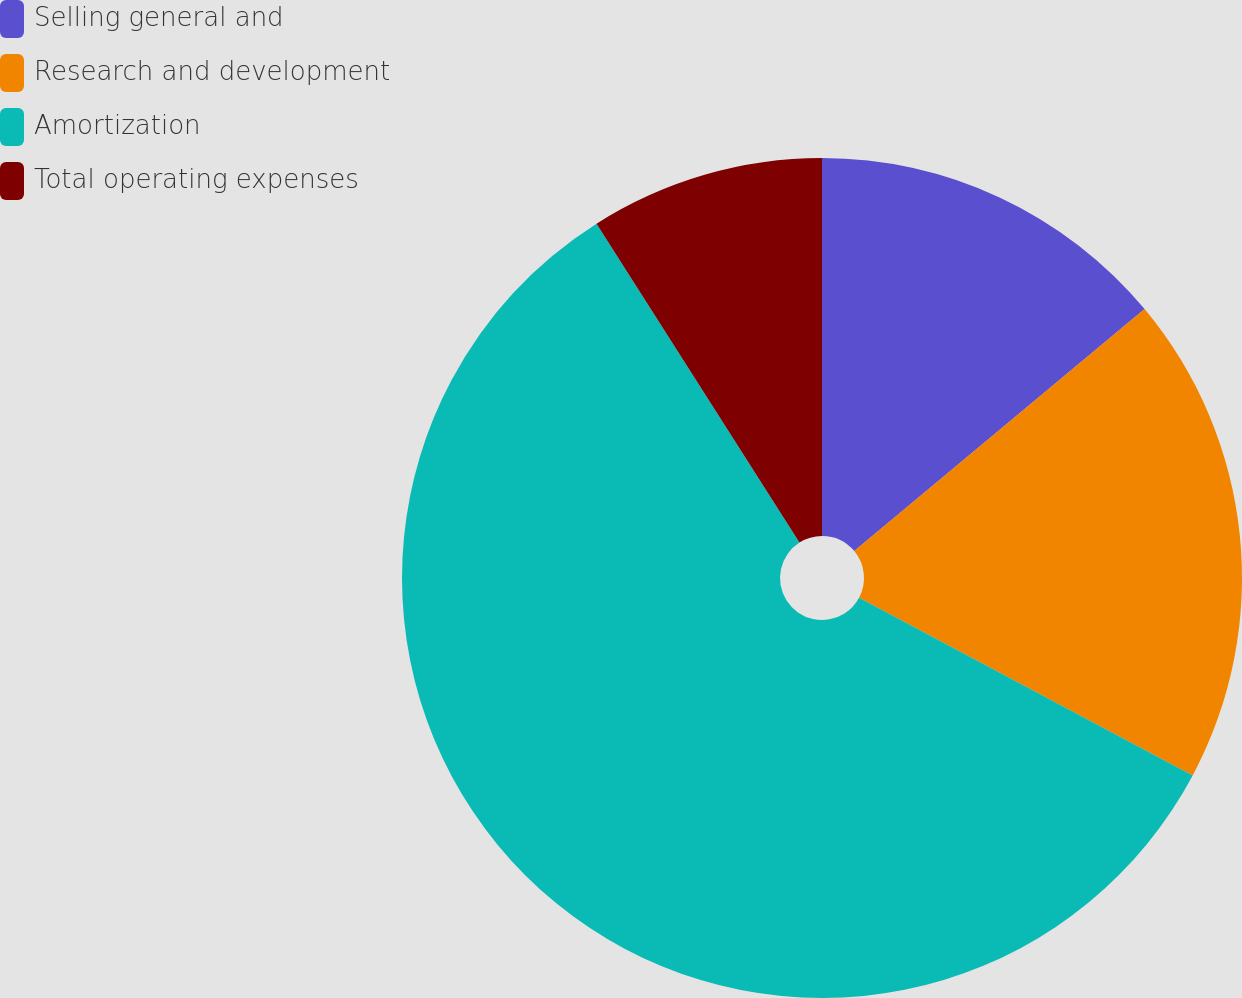<chart> <loc_0><loc_0><loc_500><loc_500><pie_chart><fcel>Selling general and<fcel>Research and development<fcel>Amortization<fcel>Total operating expenses<nl><fcel>13.94%<fcel>18.85%<fcel>58.19%<fcel>9.02%<nl></chart> 